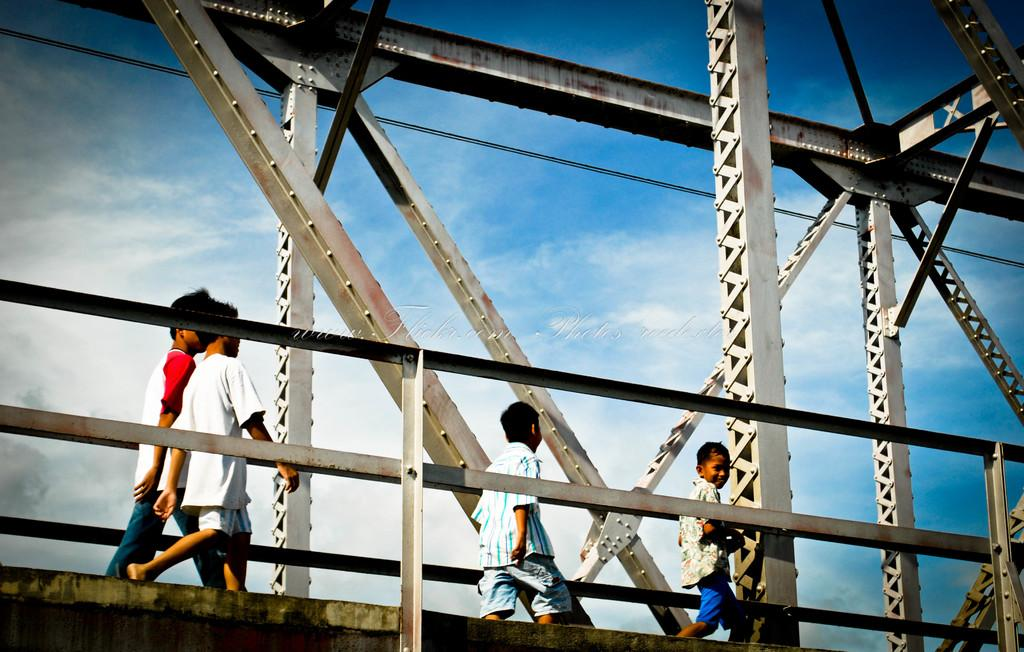What is the main structure in the picture? There is a bridge in the picture. What are the boys doing on the bridge? The boys are walking on the bridge. How would you describe the sky in the picture? The sky is blue and cloudy. How many boats are docked near the bridge in the image? There are no boats visible in the image; it only features a bridge and boys walking on it. 